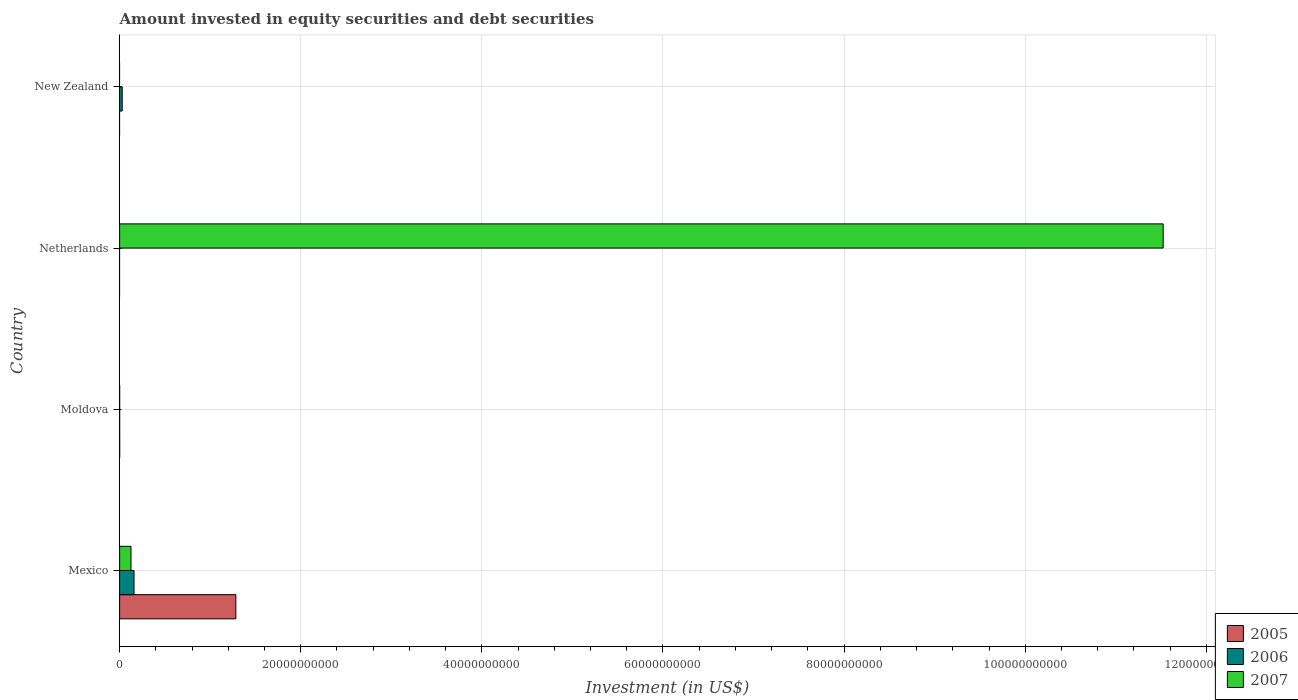How many different coloured bars are there?
Your answer should be compact. 3. Are the number of bars on each tick of the Y-axis equal?
Your answer should be compact. No. How many bars are there on the 2nd tick from the top?
Provide a succinct answer. 1. What is the label of the 3rd group of bars from the top?
Your answer should be compact. Moldova. What is the amount invested in equity securities and debt securities in 2006 in Netherlands?
Your response must be concise. 0. Across all countries, what is the maximum amount invested in equity securities and debt securities in 2005?
Keep it short and to the point. 1.28e+1. Across all countries, what is the minimum amount invested in equity securities and debt securities in 2006?
Make the answer very short. 0. What is the total amount invested in equity securities and debt securities in 2006 in the graph?
Provide a succinct answer. 1.89e+09. What is the difference between the amount invested in equity securities and debt securities in 2006 in Moldova and that in New Zealand?
Your response must be concise. -2.86e+08. What is the difference between the amount invested in equity securities and debt securities in 2007 in New Zealand and the amount invested in equity securities and debt securities in 2005 in Moldova?
Provide a short and direct response. -6.95e+06. What is the average amount invested in equity securities and debt securities in 2005 per country?
Provide a short and direct response. 3.21e+09. What is the difference between the amount invested in equity securities and debt securities in 2007 and amount invested in equity securities and debt securities in 2005 in Mexico?
Give a very brief answer. -1.16e+1. What is the ratio of the amount invested in equity securities and debt securities in 2007 in Moldova to that in Netherlands?
Your answer should be compact. 3.913809412234343e-5. What is the difference between the highest and the second highest amount invested in equity securities and debt securities in 2006?
Offer a very short reply. 1.30e+09. What is the difference between the highest and the lowest amount invested in equity securities and debt securities in 2006?
Keep it short and to the point. 1.59e+09. In how many countries, is the amount invested in equity securities and debt securities in 2005 greater than the average amount invested in equity securities and debt securities in 2005 taken over all countries?
Ensure brevity in your answer.  1. Is the sum of the amount invested in equity securities and debt securities in 2005 in Mexico and Moldova greater than the maximum amount invested in equity securities and debt securities in 2007 across all countries?
Offer a very short reply. No. Are all the bars in the graph horizontal?
Ensure brevity in your answer.  Yes. How many countries are there in the graph?
Give a very brief answer. 4. What is the difference between two consecutive major ticks on the X-axis?
Provide a succinct answer. 2.00e+1. Are the values on the major ticks of X-axis written in scientific E-notation?
Your answer should be compact. No. Does the graph contain any zero values?
Keep it short and to the point. Yes. Does the graph contain grids?
Give a very brief answer. Yes. How are the legend labels stacked?
Give a very brief answer. Vertical. What is the title of the graph?
Make the answer very short. Amount invested in equity securities and debt securities. Does "1993" appear as one of the legend labels in the graph?
Your answer should be very brief. No. What is the label or title of the X-axis?
Provide a short and direct response. Investment (in US$). What is the Investment (in US$) of 2005 in Mexico?
Your answer should be very brief. 1.28e+1. What is the Investment (in US$) in 2006 in Mexico?
Provide a short and direct response. 1.59e+09. What is the Investment (in US$) of 2007 in Mexico?
Your answer should be compact. 1.26e+09. What is the Investment (in US$) in 2005 in Moldova?
Provide a short and direct response. 6.95e+06. What is the Investment (in US$) in 2006 in Moldova?
Provide a succinct answer. 4.79e+06. What is the Investment (in US$) of 2007 in Moldova?
Provide a short and direct response. 4.51e+06. What is the Investment (in US$) in 2005 in Netherlands?
Your answer should be very brief. 0. What is the Investment (in US$) in 2006 in Netherlands?
Your answer should be very brief. 0. What is the Investment (in US$) of 2007 in Netherlands?
Your answer should be compact. 1.15e+11. What is the Investment (in US$) in 2005 in New Zealand?
Keep it short and to the point. 0. What is the Investment (in US$) of 2006 in New Zealand?
Provide a succinct answer. 2.91e+08. Across all countries, what is the maximum Investment (in US$) of 2005?
Offer a terse response. 1.28e+1. Across all countries, what is the maximum Investment (in US$) in 2006?
Make the answer very short. 1.59e+09. Across all countries, what is the maximum Investment (in US$) of 2007?
Ensure brevity in your answer.  1.15e+11. Across all countries, what is the minimum Investment (in US$) of 2005?
Offer a very short reply. 0. Across all countries, what is the minimum Investment (in US$) in 2006?
Provide a succinct answer. 0. Across all countries, what is the minimum Investment (in US$) in 2007?
Your response must be concise. 0. What is the total Investment (in US$) in 2005 in the graph?
Provide a short and direct response. 1.28e+1. What is the total Investment (in US$) of 2006 in the graph?
Your answer should be compact. 1.89e+09. What is the total Investment (in US$) of 2007 in the graph?
Ensure brevity in your answer.  1.16e+11. What is the difference between the Investment (in US$) of 2005 in Mexico and that in Moldova?
Your answer should be very brief. 1.28e+1. What is the difference between the Investment (in US$) of 2006 in Mexico and that in Moldova?
Make the answer very short. 1.59e+09. What is the difference between the Investment (in US$) in 2007 in Mexico and that in Moldova?
Your answer should be very brief. 1.25e+09. What is the difference between the Investment (in US$) in 2007 in Mexico and that in Netherlands?
Your response must be concise. -1.14e+11. What is the difference between the Investment (in US$) of 2006 in Mexico and that in New Zealand?
Provide a short and direct response. 1.30e+09. What is the difference between the Investment (in US$) of 2007 in Moldova and that in Netherlands?
Give a very brief answer. -1.15e+11. What is the difference between the Investment (in US$) in 2006 in Moldova and that in New Zealand?
Your response must be concise. -2.86e+08. What is the difference between the Investment (in US$) of 2005 in Mexico and the Investment (in US$) of 2006 in Moldova?
Offer a terse response. 1.28e+1. What is the difference between the Investment (in US$) in 2005 in Mexico and the Investment (in US$) in 2007 in Moldova?
Provide a short and direct response. 1.28e+1. What is the difference between the Investment (in US$) in 2006 in Mexico and the Investment (in US$) in 2007 in Moldova?
Keep it short and to the point. 1.59e+09. What is the difference between the Investment (in US$) of 2005 in Mexico and the Investment (in US$) of 2007 in Netherlands?
Your answer should be very brief. -1.02e+11. What is the difference between the Investment (in US$) in 2006 in Mexico and the Investment (in US$) in 2007 in Netherlands?
Your answer should be compact. -1.14e+11. What is the difference between the Investment (in US$) of 2005 in Mexico and the Investment (in US$) of 2006 in New Zealand?
Your answer should be very brief. 1.25e+1. What is the difference between the Investment (in US$) in 2005 in Moldova and the Investment (in US$) in 2007 in Netherlands?
Provide a short and direct response. -1.15e+11. What is the difference between the Investment (in US$) in 2006 in Moldova and the Investment (in US$) in 2007 in Netherlands?
Offer a terse response. -1.15e+11. What is the difference between the Investment (in US$) in 2005 in Moldova and the Investment (in US$) in 2006 in New Zealand?
Your answer should be compact. -2.84e+08. What is the average Investment (in US$) of 2005 per country?
Provide a short and direct response. 3.21e+09. What is the average Investment (in US$) in 2006 per country?
Your response must be concise. 4.72e+08. What is the average Investment (in US$) of 2007 per country?
Offer a terse response. 2.91e+1. What is the difference between the Investment (in US$) of 2005 and Investment (in US$) of 2006 in Mexico?
Offer a terse response. 1.12e+1. What is the difference between the Investment (in US$) of 2005 and Investment (in US$) of 2007 in Mexico?
Ensure brevity in your answer.  1.16e+1. What is the difference between the Investment (in US$) of 2006 and Investment (in US$) of 2007 in Mexico?
Offer a terse response. 3.35e+08. What is the difference between the Investment (in US$) in 2005 and Investment (in US$) in 2006 in Moldova?
Make the answer very short. 2.16e+06. What is the difference between the Investment (in US$) of 2005 and Investment (in US$) of 2007 in Moldova?
Provide a short and direct response. 2.44e+06. What is the difference between the Investment (in US$) of 2006 and Investment (in US$) of 2007 in Moldova?
Your response must be concise. 2.80e+05. What is the ratio of the Investment (in US$) in 2005 in Mexico to that in Moldova?
Your answer should be very brief. 1846.7. What is the ratio of the Investment (in US$) of 2006 in Mexico to that in Moldova?
Your answer should be compact. 332.32. What is the ratio of the Investment (in US$) of 2007 in Mexico to that in Moldova?
Your answer should be very brief. 278.7. What is the ratio of the Investment (in US$) in 2007 in Mexico to that in Netherlands?
Make the answer very short. 0.01. What is the ratio of the Investment (in US$) of 2006 in Mexico to that in New Zealand?
Your response must be concise. 5.48. What is the ratio of the Investment (in US$) of 2007 in Moldova to that in Netherlands?
Give a very brief answer. 0. What is the ratio of the Investment (in US$) in 2006 in Moldova to that in New Zealand?
Offer a terse response. 0.02. What is the difference between the highest and the second highest Investment (in US$) in 2006?
Provide a short and direct response. 1.30e+09. What is the difference between the highest and the second highest Investment (in US$) of 2007?
Keep it short and to the point. 1.14e+11. What is the difference between the highest and the lowest Investment (in US$) of 2005?
Keep it short and to the point. 1.28e+1. What is the difference between the highest and the lowest Investment (in US$) of 2006?
Give a very brief answer. 1.59e+09. What is the difference between the highest and the lowest Investment (in US$) in 2007?
Your answer should be very brief. 1.15e+11. 